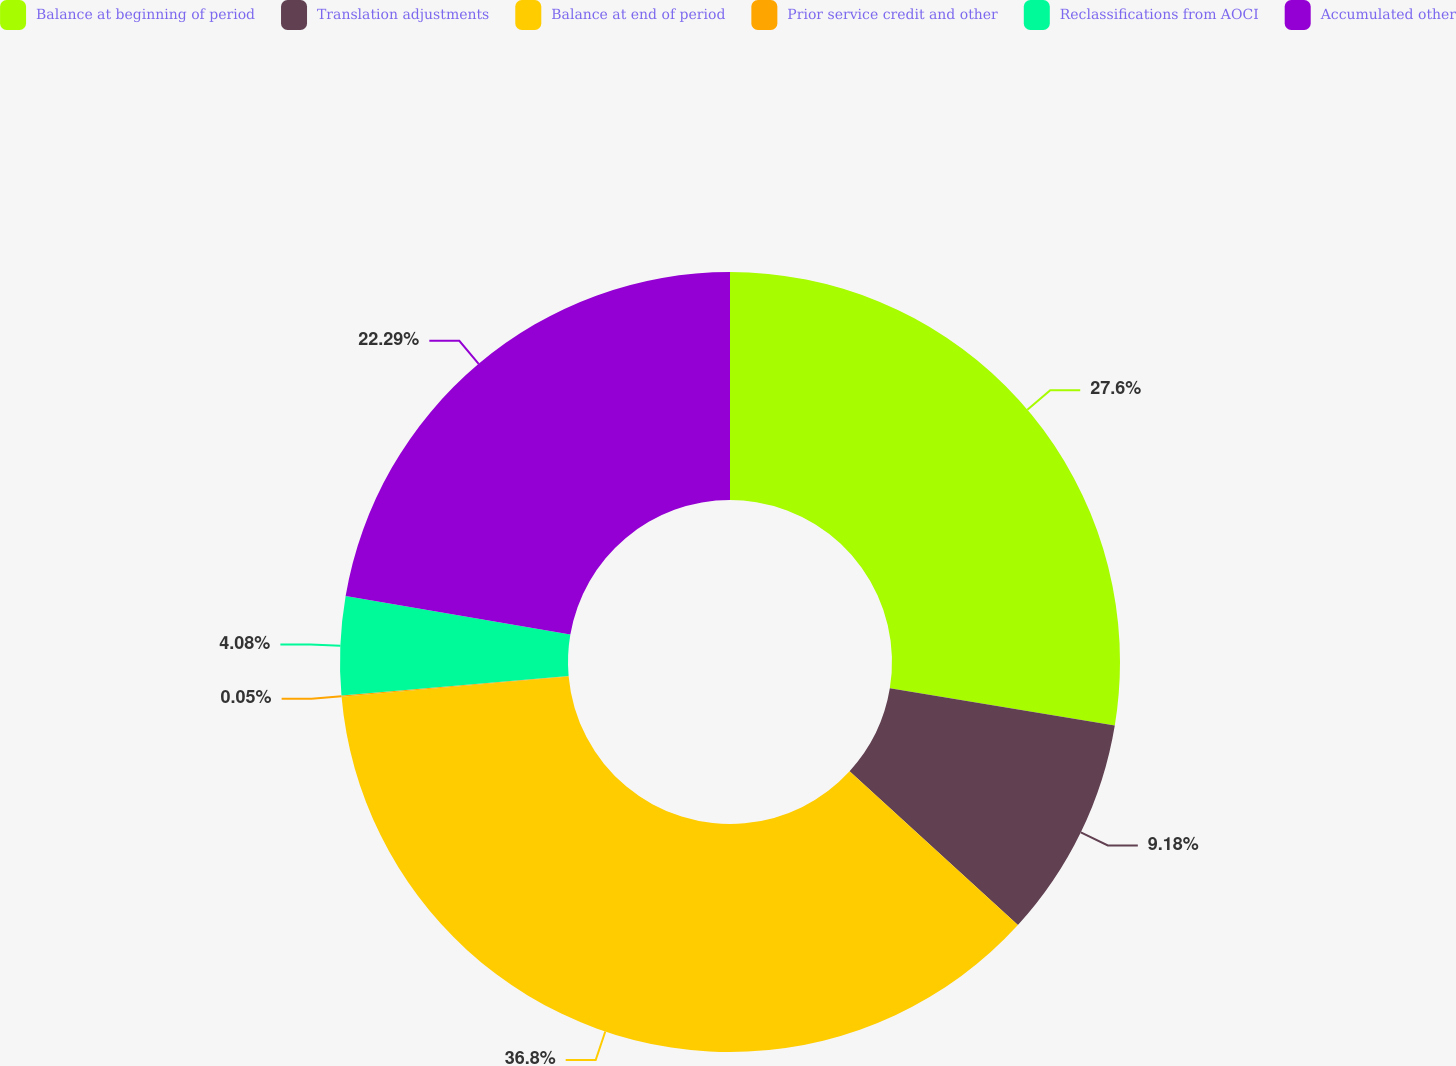<chart> <loc_0><loc_0><loc_500><loc_500><pie_chart><fcel>Balance at beginning of period<fcel>Translation adjustments<fcel>Balance at end of period<fcel>Prior service credit and other<fcel>Reclassifications from AOCI<fcel>Accumulated other<nl><fcel>27.6%<fcel>9.18%<fcel>36.79%<fcel>0.05%<fcel>4.08%<fcel>22.29%<nl></chart> 